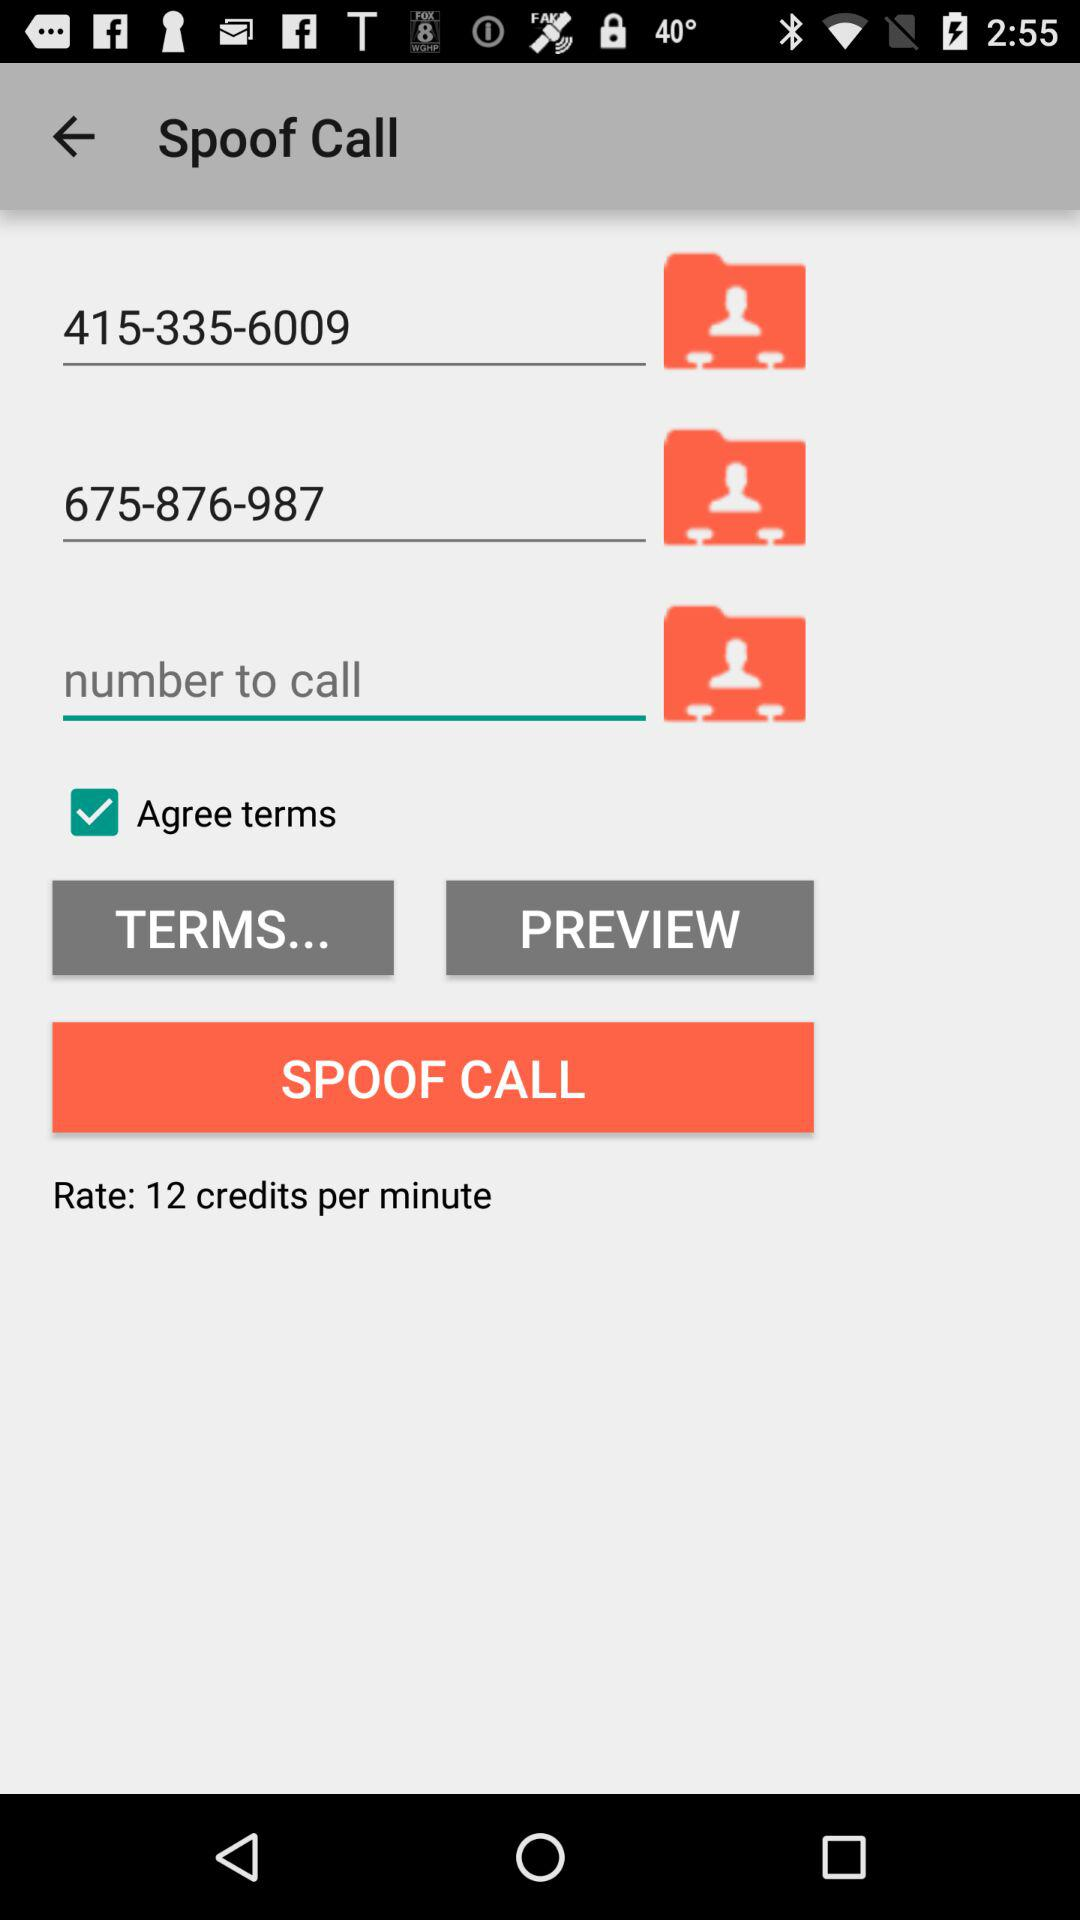How many credits per minute is the rate?
Answer the question using a single word or phrase. 12 